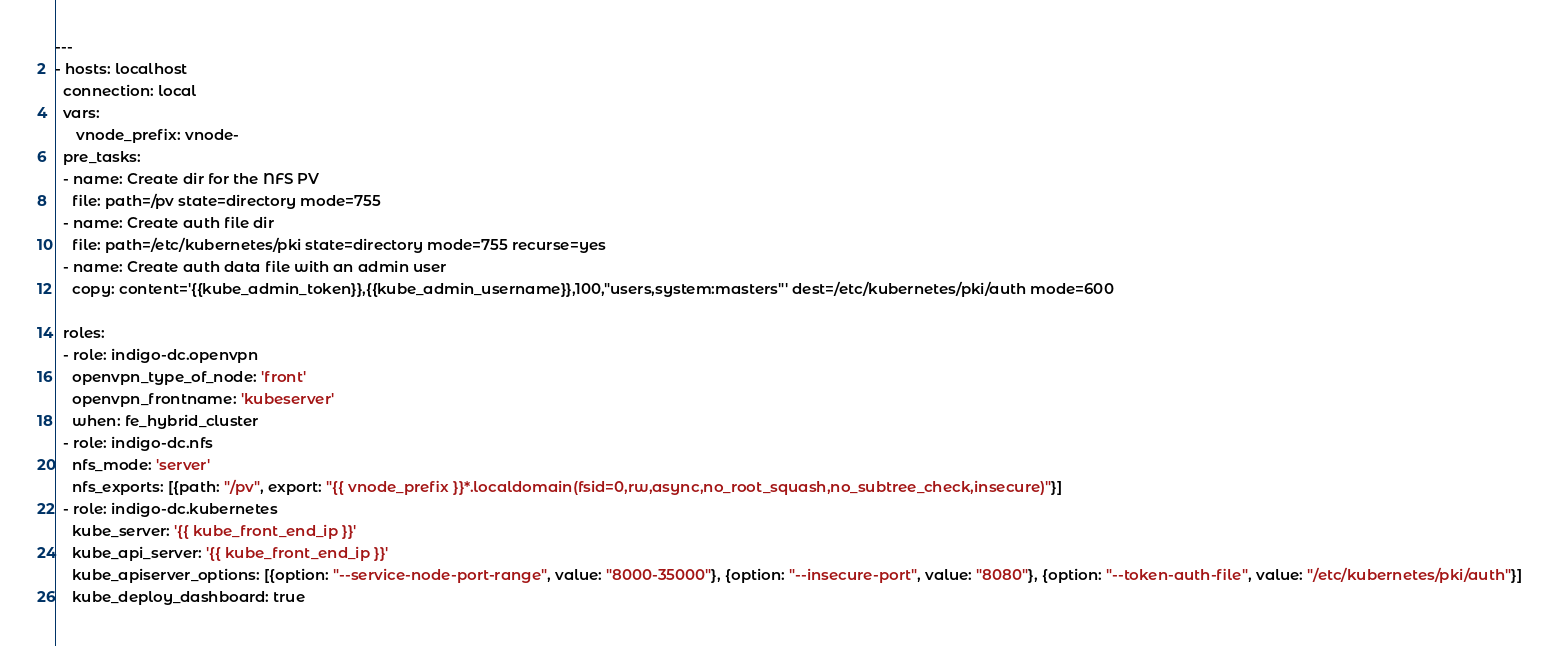Convert code to text. <code><loc_0><loc_0><loc_500><loc_500><_YAML_>---
- hosts: localhost
  connection: local
  vars:
     vnode_prefix: vnode-
  pre_tasks:
  - name: Create dir for the NFS PV
    file: path=/pv state=directory mode=755
  - name: Create auth file dir
    file: path=/etc/kubernetes/pki state=directory mode=755 recurse=yes
  - name: Create auth data file with an admin user
    copy: content='{{kube_admin_token}},{{kube_admin_username}},100,"users,system:masters"' dest=/etc/kubernetes/pki/auth mode=600

  roles:
  - role: indigo-dc.openvpn
    openvpn_type_of_node: 'front'
    openvpn_frontname: 'kubeserver'
    when: fe_hybrid_cluster
  - role: indigo-dc.nfs
    nfs_mode: 'server'
    nfs_exports: [{path: "/pv", export: "{{ vnode_prefix }}*.localdomain(fsid=0,rw,async,no_root_squash,no_subtree_check,insecure)"}]
  - role: indigo-dc.kubernetes
    kube_server: '{{ kube_front_end_ip }}'
    kube_api_server: '{{ kube_front_end_ip }}'
    kube_apiserver_options: [{option: "--service-node-port-range", value: "8000-35000"}, {option: "--insecure-port", value: "8080"}, {option: "--token-auth-file", value: "/etc/kubernetes/pki/auth"}]
    kube_deploy_dashboard: true
</code> 